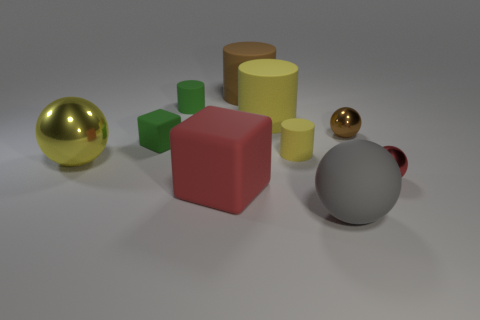What number of other things are the same size as the red rubber thing?
Offer a very short reply. 4. Is the number of large yellow things that are in front of the yellow metal object greater than the number of gray rubber things?
Your answer should be compact. No. Is there anything else that has the same color as the rubber sphere?
Make the answer very short. No. What shape is the gray object that is made of the same material as the green cylinder?
Offer a terse response. Sphere. Do the red thing that is on the left side of the gray object and the small green block have the same material?
Your response must be concise. Yes. The thing that is the same color as the large rubber cube is what shape?
Keep it short and to the point. Sphere. There is a metallic object that is to the left of the tiny brown sphere; is its color the same as the large cylinder to the right of the large brown matte cylinder?
Provide a succinct answer. Yes. What number of rubber things are behind the brown shiny sphere and in front of the large rubber cube?
Provide a short and direct response. 0. What is the material of the gray thing?
Provide a short and direct response. Rubber. What shape is the brown rubber thing that is the same size as the rubber sphere?
Ensure brevity in your answer.  Cylinder. 